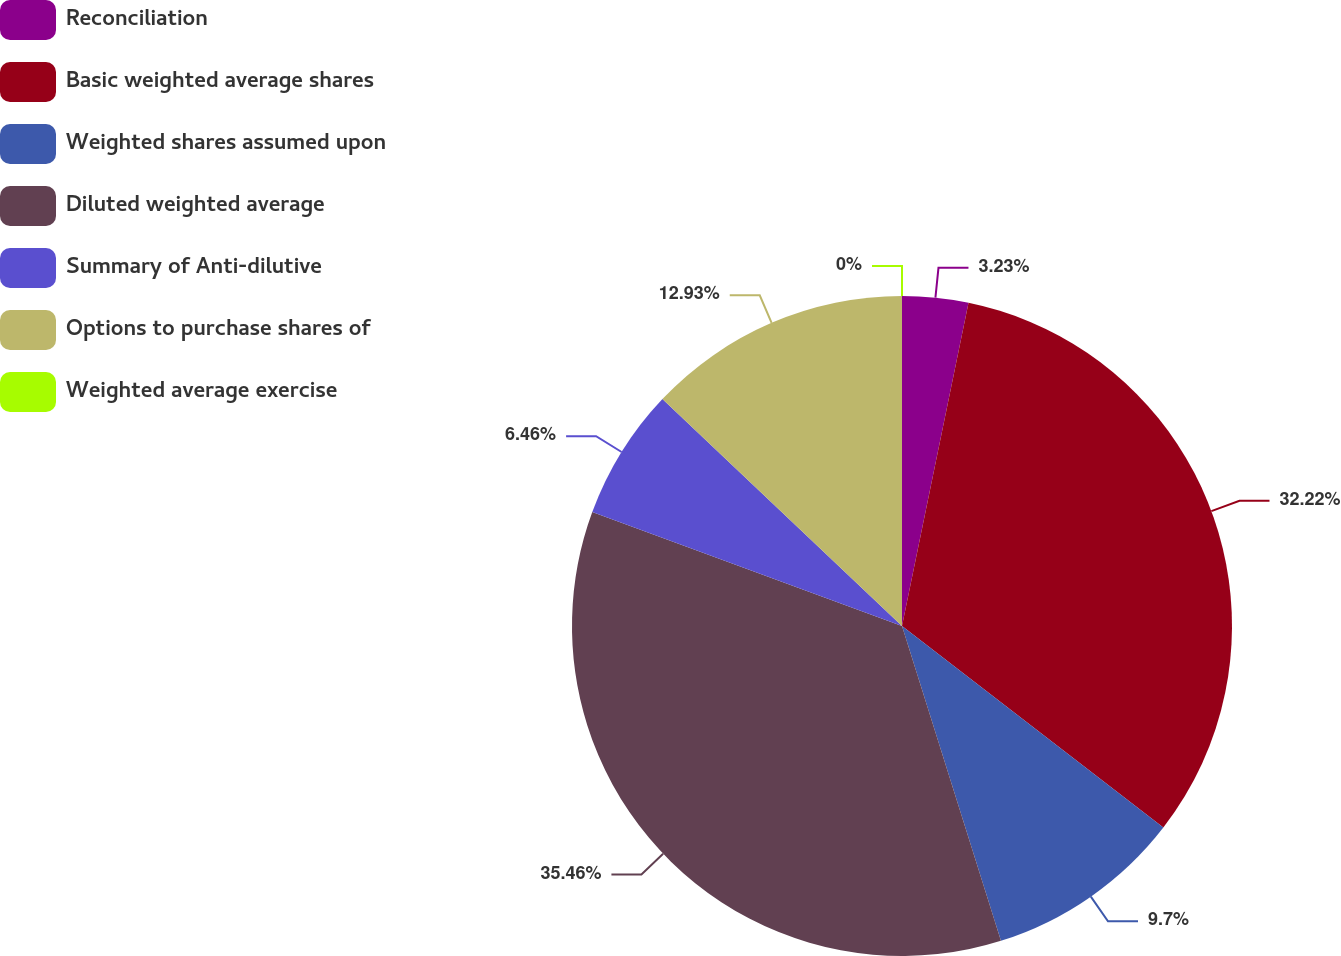<chart> <loc_0><loc_0><loc_500><loc_500><pie_chart><fcel>Reconciliation<fcel>Basic weighted average shares<fcel>Weighted shares assumed upon<fcel>Diluted weighted average<fcel>Summary of Anti-dilutive<fcel>Options to purchase shares of<fcel>Weighted average exercise<nl><fcel>3.23%<fcel>32.22%<fcel>9.7%<fcel>35.45%<fcel>6.46%<fcel>12.93%<fcel>0.0%<nl></chart> 